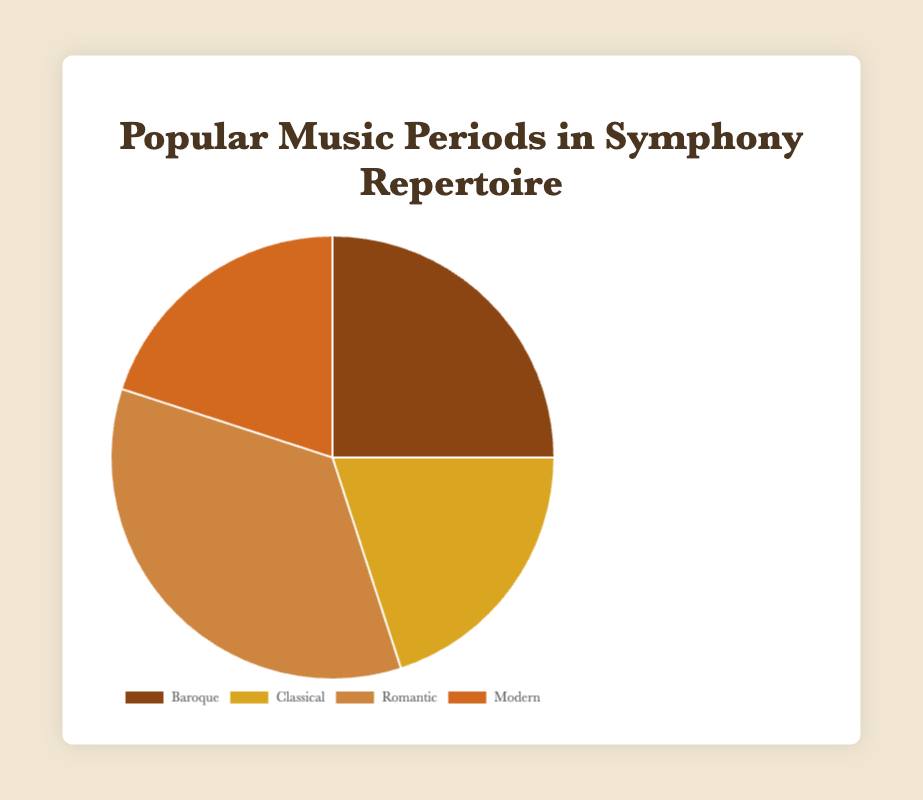What is the most popular music period in the symphony repertoire according to the pie chart? The "Romantic" period dominates the chart with 35%, which is the highest among all periods.
Answer: Romantic Which two periods have the same percentage in the chart, and what is that percentage? The "Classical" and "Modern" periods both have a percentage of 20%.
Answer: Classical and Modern, 20% By looking at the colors used in the pie chart, which period is represented by the darkest shade of brown? The darkest shade of brown in the pie chart corresponds to the "Baroque" period.
Answer: Baroque What is the combined percentage of the Classical and Modern periods? The "Classical" period has 20%, and the "Modern" period also has 20%. Adding these gives 20% + 20% = 40%.
Answer: 40% How much larger, in percentage points, is the Romantic period compared to the Baroque period? The "Romantic" period is 35%, and the "Baroque" period is 25%. The difference is 35% - 25% = 10%.
Answer: 10% Which period accounts for a quarter of the symphony repertoire? The percentage for the "Baroque" period is 25%, which is a quarter of 100%.
Answer: Baroque If you were to merge the Baroque and Modern periods, what would be their combined percentage? The "Baroque" period is 25%, and the "Modern" period is 20%. Their combined percentage is 25% + 20% = 45%.
Answer: 45% Compare the Romantic period to the sum of Classical and Modern periods in terms of percentages. Which is larger and by how much? The "Romantic" period is 35%. The sum of "Classical" and "Modern" is 20% + 20% = 40%. The combined percentage of "Classical" and "Modern" is larger by 40% - 35% = 5%.
Answer: Sum of Classical and Modern, by 5% Which period is represented by the lightest shade of brown in the pie chart? The lightest shade of brown in the pie chart corresponds to the "Classical" period.
Answer: Classical 